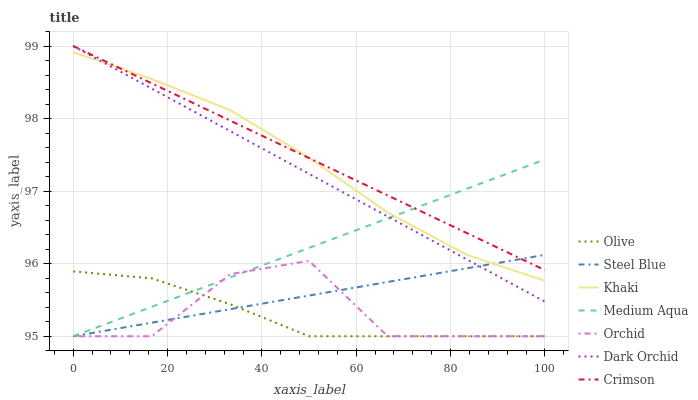Does Olive have the minimum area under the curve?
Answer yes or no. Yes. Does Crimson have the maximum area under the curve?
Answer yes or no. Yes. Does Steel Blue have the minimum area under the curve?
Answer yes or no. No. Does Steel Blue have the maximum area under the curve?
Answer yes or no. No. Is Dark Orchid the smoothest?
Answer yes or no. Yes. Is Orchid the roughest?
Answer yes or no. Yes. Is Steel Blue the smoothest?
Answer yes or no. No. Is Steel Blue the roughest?
Answer yes or no. No. Does Dark Orchid have the lowest value?
Answer yes or no. No. Does Crimson have the highest value?
Answer yes or no. Yes. Does Steel Blue have the highest value?
Answer yes or no. No. Is Olive less than Dark Orchid?
Answer yes or no. Yes. Is Khaki greater than Olive?
Answer yes or no. Yes. Does Olive intersect Dark Orchid?
Answer yes or no. No. 